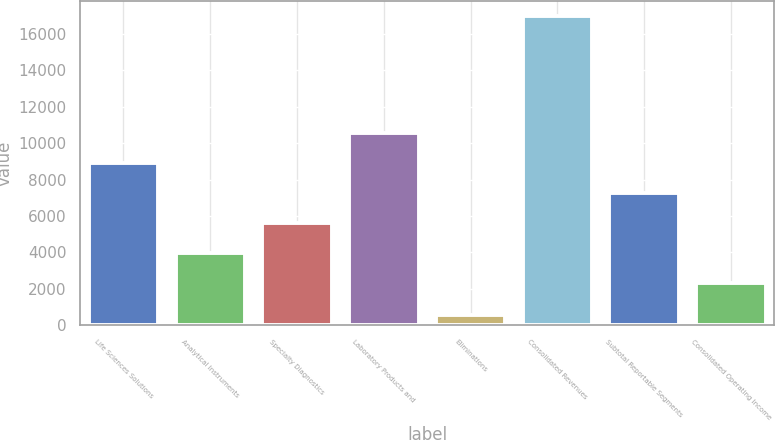Convert chart. <chart><loc_0><loc_0><loc_500><loc_500><bar_chart><fcel>Life Sciences Solutions<fcel>Analytical Instruments<fcel>Specialty Diagnostics<fcel>Laboratory Products and<fcel>Eliminations<fcel>Consolidated Revenues<fcel>Subtotal Reportable Segments<fcel>Consolidated Operating Income<nl><fcel>8887.32<fcel>3973.98<fcel>5611.76<fcel>10525.1<fcel>587.6<fcel>16965.4<fcel>7249.54<fcel>2336.2<nl></chart> 